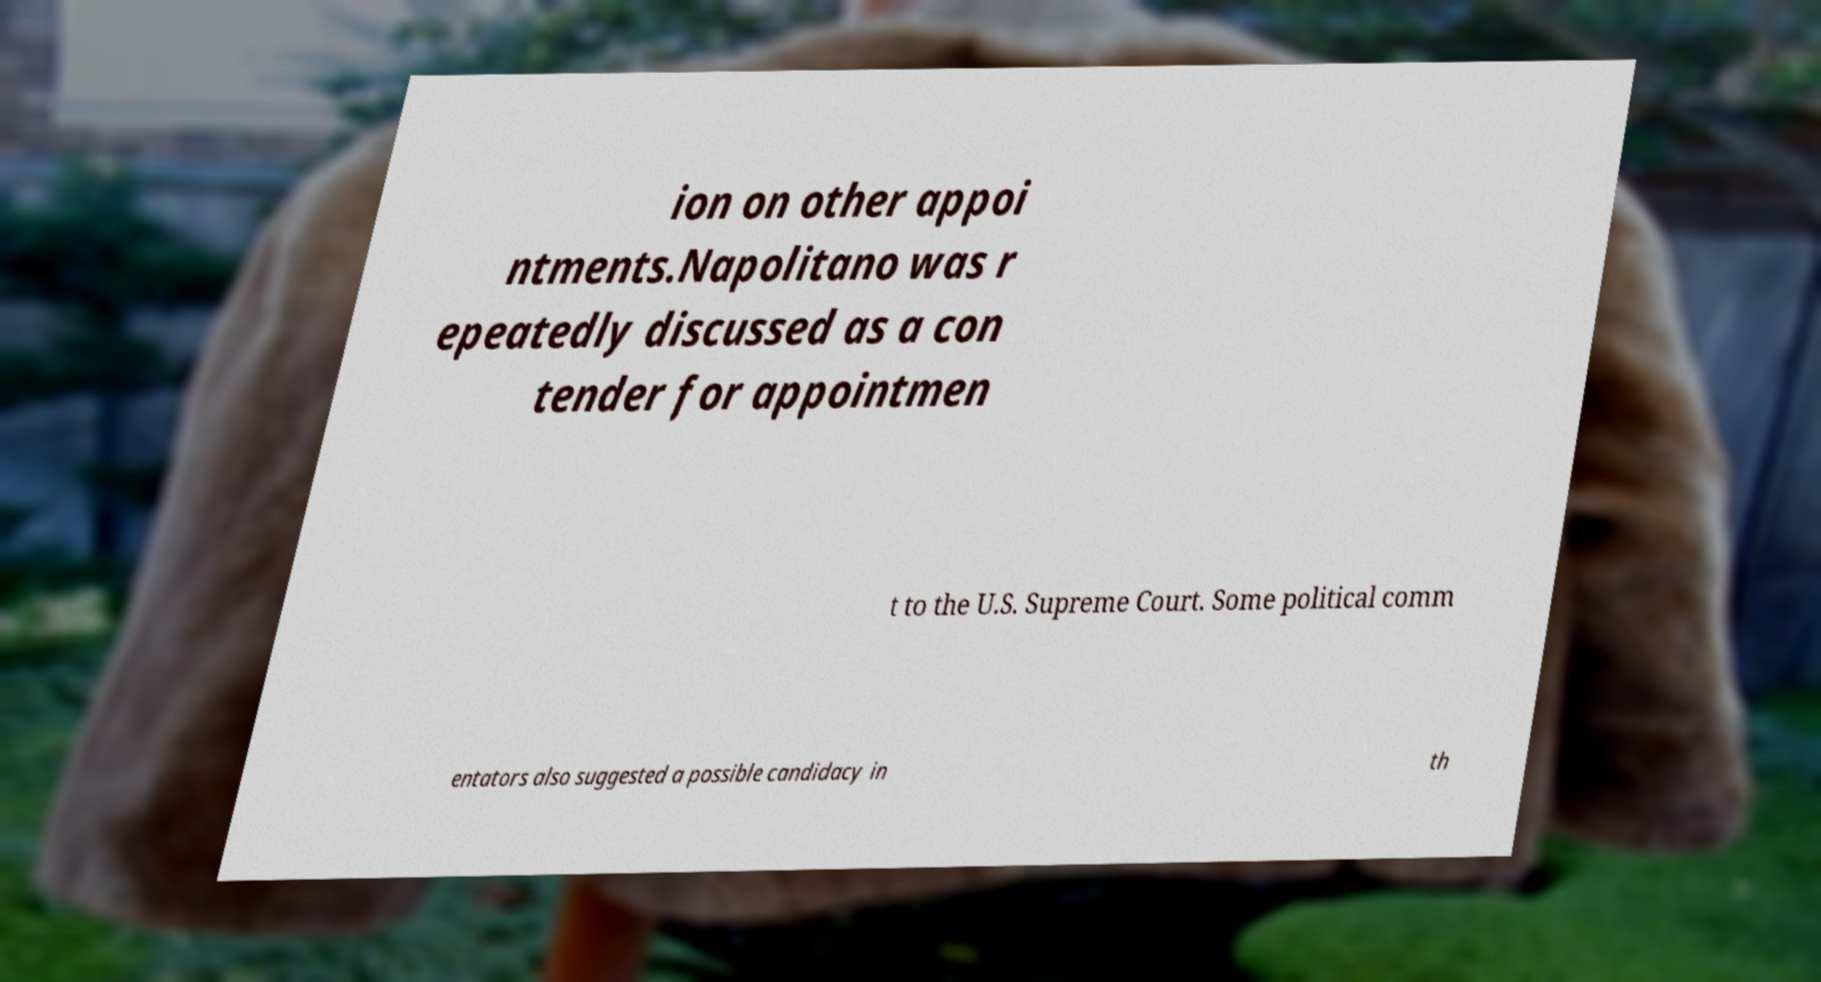Can you accurately transcribe the text from the provided image for me? ion on other appoi ntments.Napolitano was r epeatedly discussed as a con tender for appointmen t to the U.S. Supreme Court. Some political comm entators also suggested a possible candidacy in th 